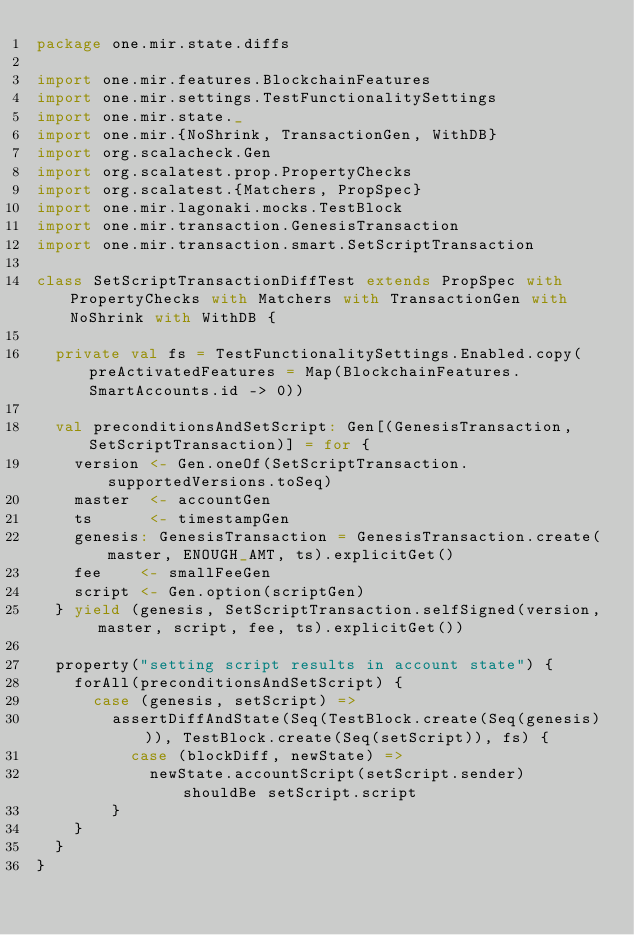<code> <loc_0><loc_0><loc_500><loc_500><_Scala_>package one.mir.state.diffs

import one.mir.features.BlockchainFeatures
import one.mir.settings.TestFunctionalitySettings
import one.mir.state._
import one.mir.{NoShrink, TransactionGen, WithDB}
import org.scalacheck.Gen
import org.scalatest.prop.PropertyChecks
import org.scalatest.{Matchers, PropSpec}
import one.mir.lagonaki.mocks.TestBlock
import one.mir.transaction.GenesisTransaction
import one.mir.transaction.smart.SetScriptTransaction

class SetScriptTransactionDiffTest extends PropSpec with PropertyChecks with Matchers with TransactionGen with NoShrink with WithDB {

  private val fs = TestFunctionalitySettings.Enabled.copy(preActivatedFeatures = Map(BlockchainFeatures.SmartAccounts.id -> 0))

  val preconditionsAndSetScript: Gen[(GenesisTransaction, SetScriptTransaction)] = for {
    version <- Gen.oneOf(SetScriptTransaction.supportedVersions.toSeq)
    master  <- accountGen
    ts      <- timestampGen
    genesis: GenesisTransaction = GenesisTransaction.create(master, ENOUGH_AMT, ts).explicitGet()
    fee    <- smallFeeGen
    script <- Gen.option(scriptGen)
  } yield (genesis, SetScriptTransaction.selfSigned(version, master, script, fee, ts).explicitGet())

  property("setting script results in account state") {
    forAll(preconditionsAndSetScript) {
      case (genesis, setScript) =>
        assertDiffAndState(Seq(TestBlock.create(Seq(genesis))), TestBlock.create(Seq(setScript)), fs) {
          case (blockDiff, newState) =>
            newState.accountScript(setScript.sender) shouldBe setScript.script
        }
    }
  }
}
</code> 